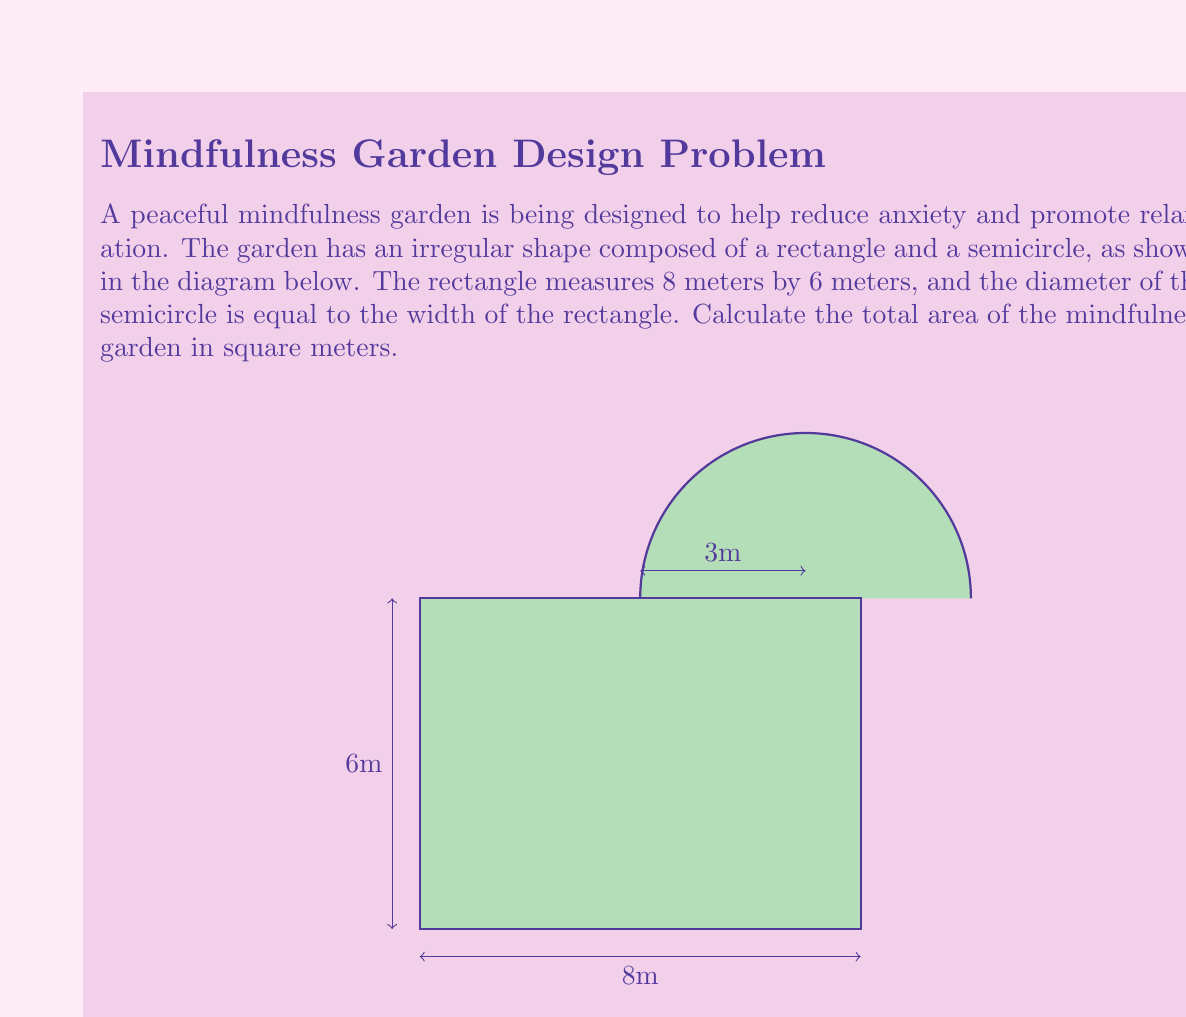Can you answer this question? Let's approach this problem step-by-step:

1) First, we need to calculate the area of the rectangle:
   $$A_{rectangle} = length \times width = 8 \text{ m} \times 6 \text{ m} = 48 \text{ m}^2$$

2) Next, we need to calculate the area of the semicircle:
   - The diameter of the semicircle is equal to the width of the rectangle, which is 6 m.
   - The radius is half of this, so $r = 3 \text{ m}$.
   - The formula for the area of a semicircle is: $A_{semicircle} = \frac{1}{2} \times \pi r^2$
   
   $$A_{semicircle} = \frac{1}{2} \times \pi \times 3^2 = \frac{9\pi}{2} \text{ m}^2$$

3) The total area of the mindfulness garden is the sum of these two areas:

   $$A_{total} = A_{rectangle} + A_{semicircle} = 48 + \frac{9\pi}{2} \text{ m}^2$$

4) We can simplify this further:
   $$A_{total} = 48 + 4.5\pi \approx 62.12 \text{ m}^2$$

Therefore, the total area of the mindfulness garden is approximately 62.12 square meters.
Answer: $48 + \frac{9\pi}{2} \text{ m}^2$ or approximately $62.12 \text{ m}^2$ 